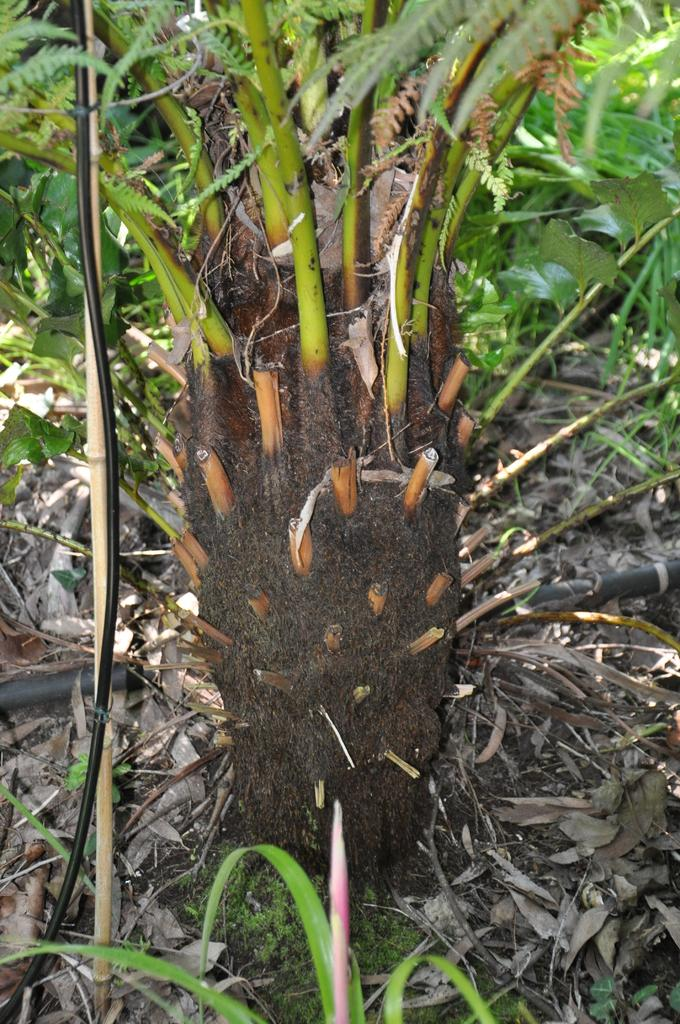What type of living organism can be seen in the image? There is a plant in the image. What is visible at the bottom of the image? The ground is visible at the bottom of the image. What can be observed on the ground in the image? There are dry leaves on the ground. What type of ray is swimming in the image? There is no ray present in the image; it features a plant and dry leaves on the ground. Who is the judge in the argument depicted in the image? There is no argument or judge present in the image; it only shows a plant, the ground, and dry leaves. 